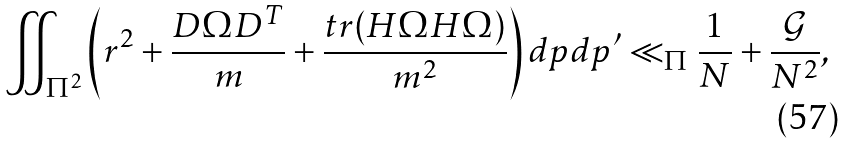<formula> <loc_0><loc_0><loc_500><loc_500>\iint _ { \Pi ^ { 2 } } \left ( r ^ { 2 } + \frac { D \Omega D ^ { T } } { m } + \frac { t r ( H \Omega H \Omega ) } { m ^ { 2 } } \right ) d p d p ^ { \prime } \ll _ { \Pi } \frac { 1 } { N } + \frac { \mathcal { G } } { N ^ { 2 } } ,</formula> 